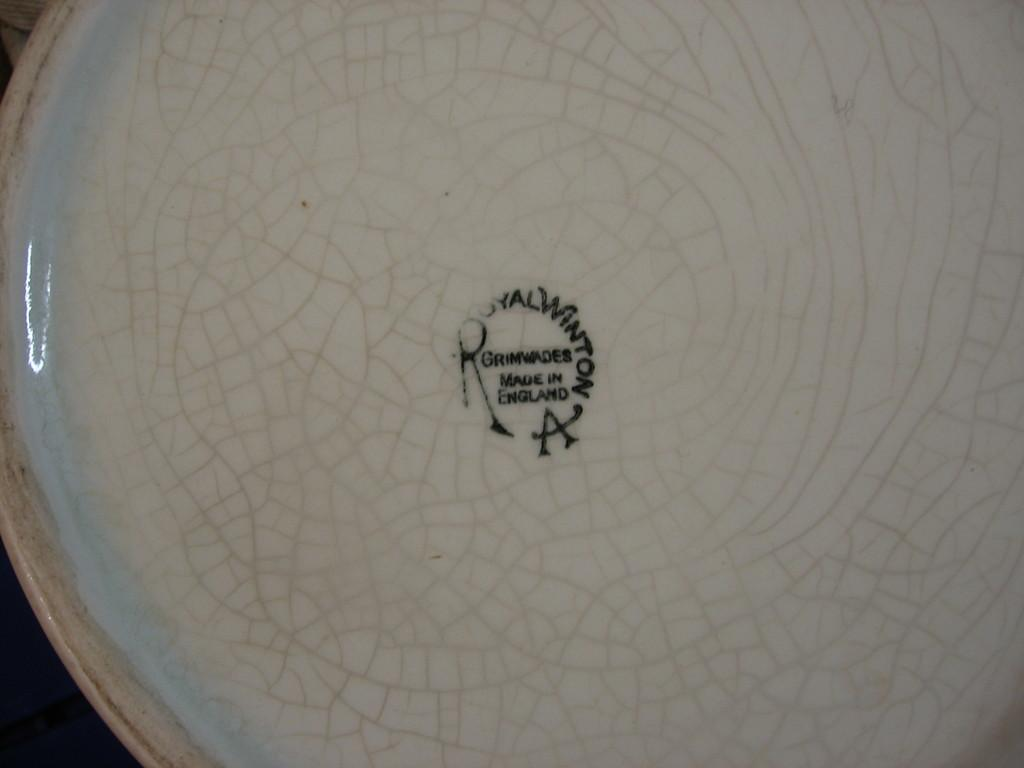What is the color of the main object in the image? The main object in the image is in white color. What does the object in the image resemble? The object resembles a plate. What is written on the object in the image? There is text written in black color in the middle of the image. Is there any gold decoration on the plate in the image? There is no mention of gold decoration on the plate in the image. Can you see a crow perched on the plate in the image? There is no crow present in the image. 